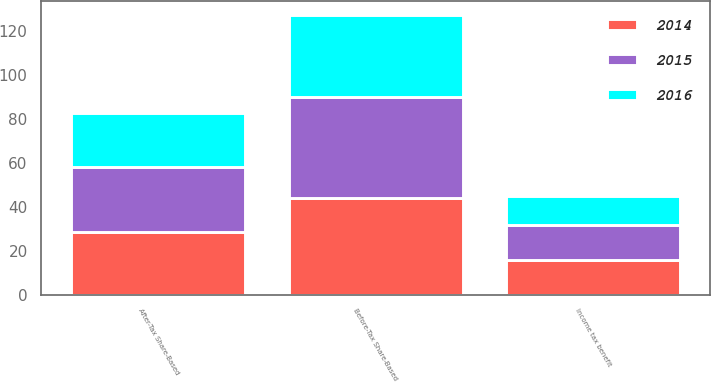Convert chart to OTSL. <chart><loc_0><loc_0><loc_500><loc_500><stacked_bar_chart><ecel><fcel>Before-Tax Share-Based<fcel>Income tax benefit<fcel>After-Tax Share-Based<nl><fcel>2016<fcel>37.6<fcel>13.1<fcel>24.5<nl><fcel>2015<fcel>45.7<fcel>16<fcel>29.7<nl><fcel>2014<fcel>44<fcel>15.6<fcel>28.4<nl></chart> 